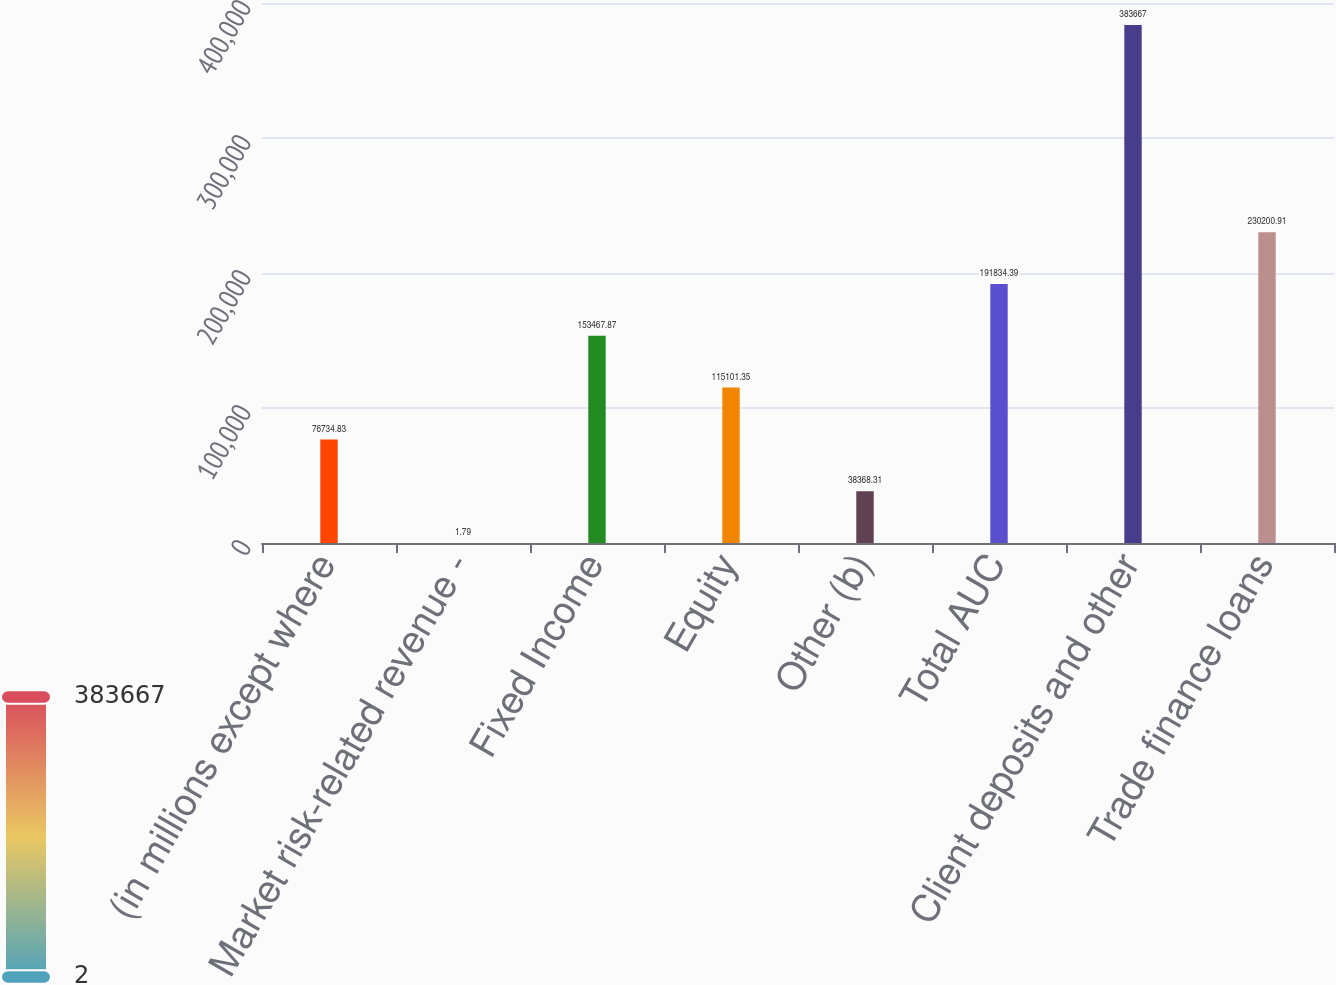<chart> <loc_0><loc_0><loc_500><loc_500><bar_chart><fcel>(in millions except where<fcel>Market risk-related revenue -<fcel>Fixed Income<fcel>Equity<fcel>Other (b)<fcel>Total AUC<fcel>Client deposits and other<fcel>Trade finance loans<nl><fcel>76734.8<fcel>1.79<fcel>153468<fcel>115101<fcel>38368.3<fcel>191834<fcel>383667<fcel>230201<nl></chart> 